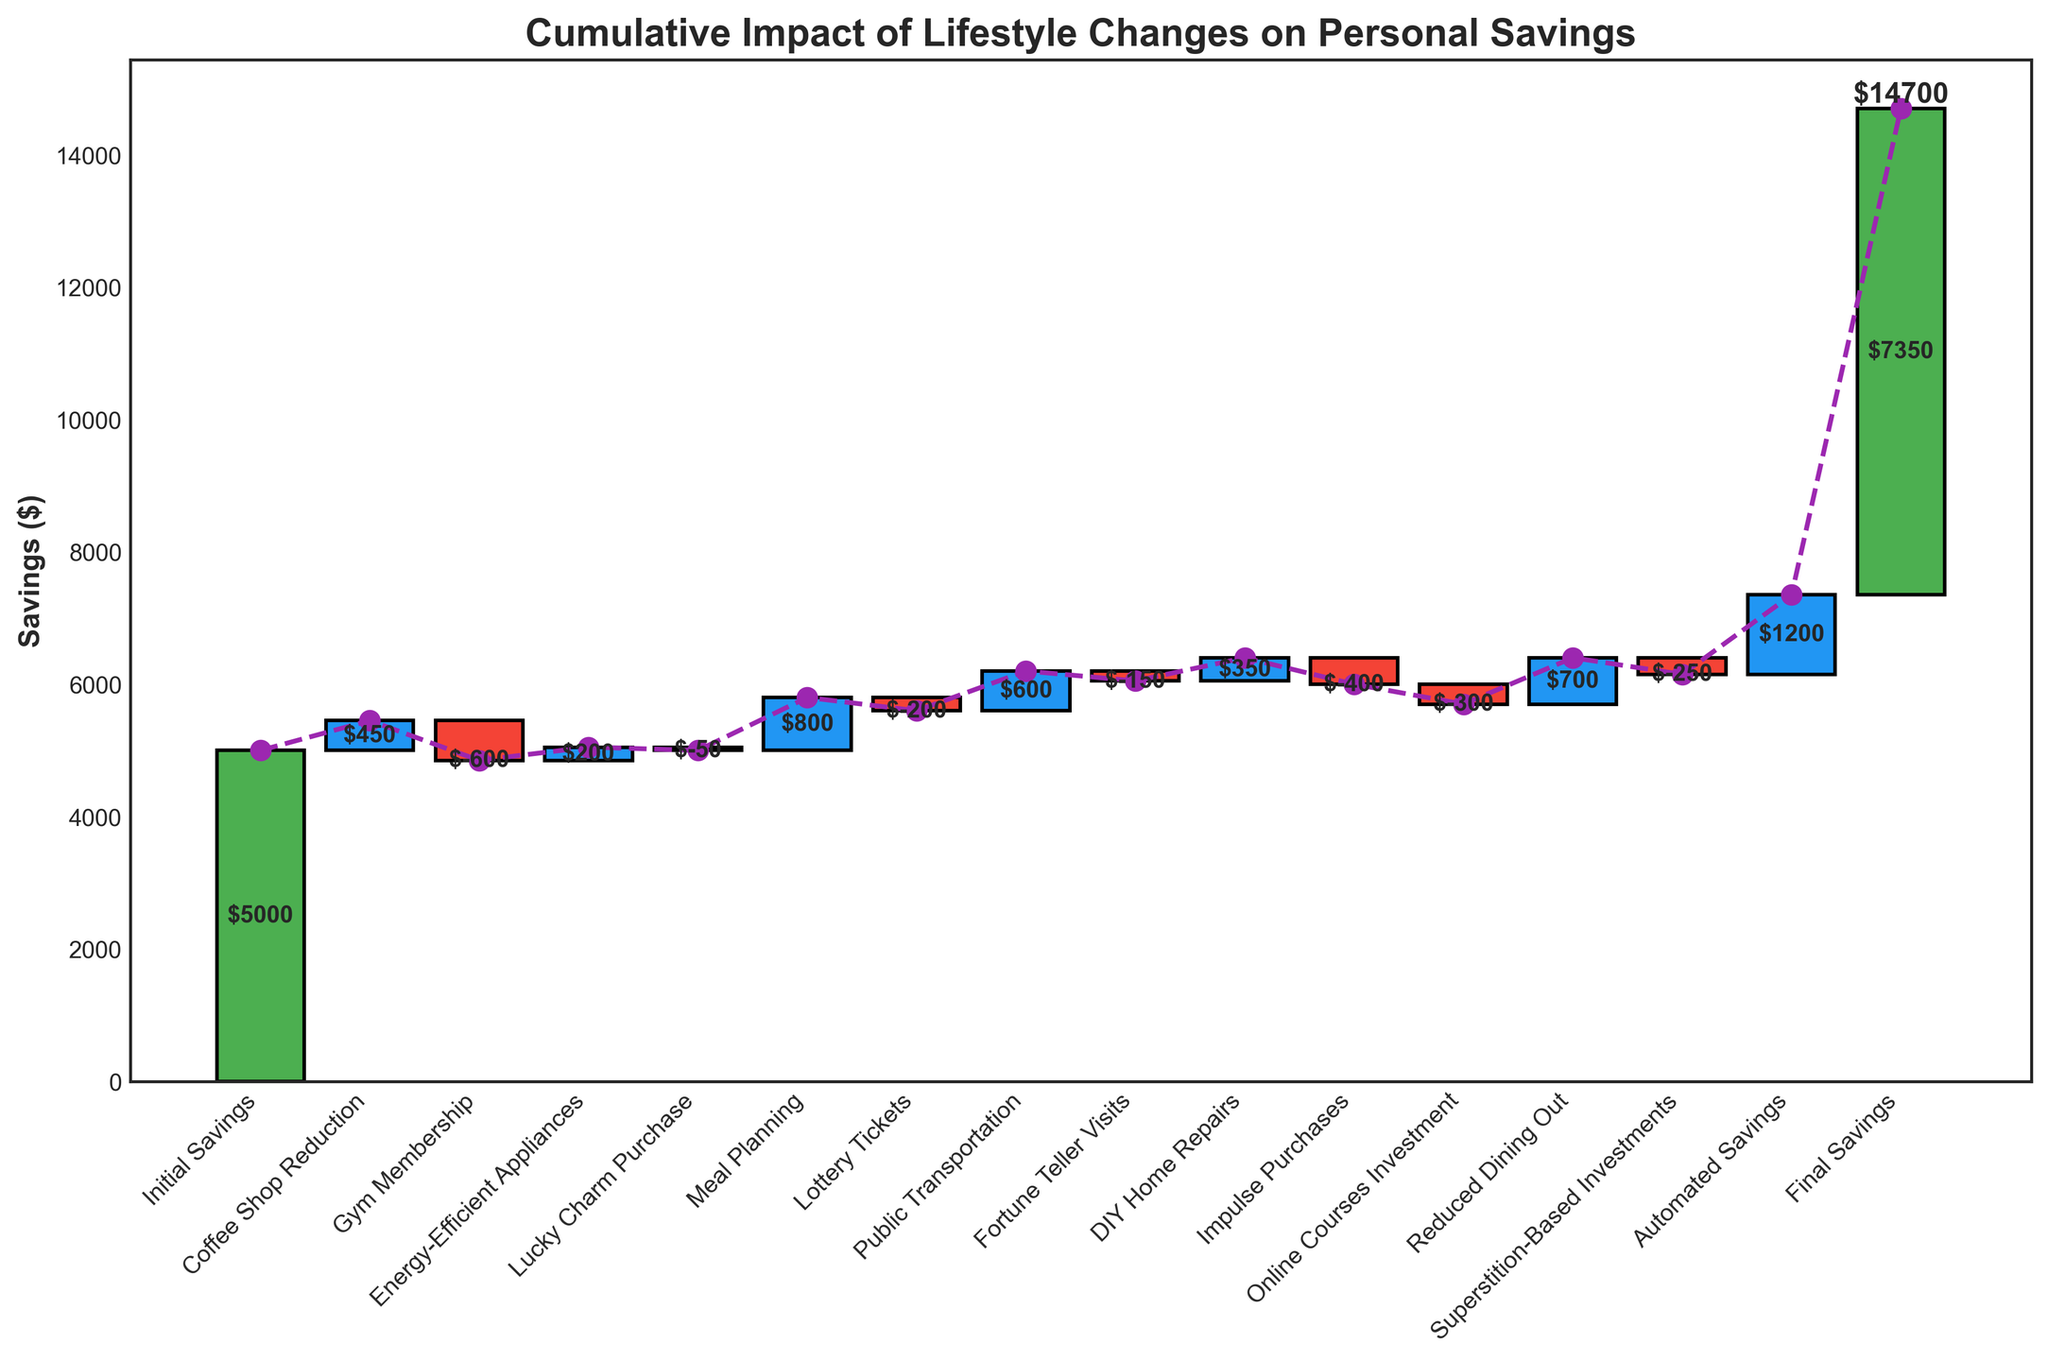What is the initial savings amount? The chart shows the initial savings amount as the first bar on the left side.
Answer: $5000 How much did switching to public transportation save over the year? The bar representing public transportation savings is labeled with the amount saved.
Answer: $600 What is the impact of gym membership expenses on savings? The gym membership expense is shown as a negative bar with the amount specified.
Answer: -$600 What is the net effect of meal planning and reduced dining out on savings? The savings from meal planning and reduced dining out can be summed: $800 (meal planning) + $700 (reduced dining out) = $1500
Answer: $1500 Which expense category had the largest negative impact on savings? Among the negative bars, the gym membership expense of $-600 is the largest.
Answer: Gym Membership What is the total positive impact on savings from all beneficial lifestyle changes? Adding all the positive changes: $450 (coffee shop reduction) + $200 (energy-efficient appliances) + $800 (meal planning) + $600 (public transportation) + $350 (DIY home repairs) + $700 (reduced dining out) + $1200 (automated savings) = $4300
Answer: $4300 How much did the fortune teller visits and superstition-based investments cost together? The costs are summed up: $-150 (fortune teller visits) + $-250 (superstition-based investments) = $-400
Answer: $-400 What was the final savings amount after all lifestyle changes? The final savings amount is indicated by the last bar on the right.
Answer: $7350 Which lifestyle change had the highest positive impact on savings? Among the positive bars, the automated savings of $1200 is the highest.
Answer: Automated Savings 